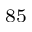<formula> <loc_0><loc_0><loc_500><loc_500>^ { 8 5 }</formula> 